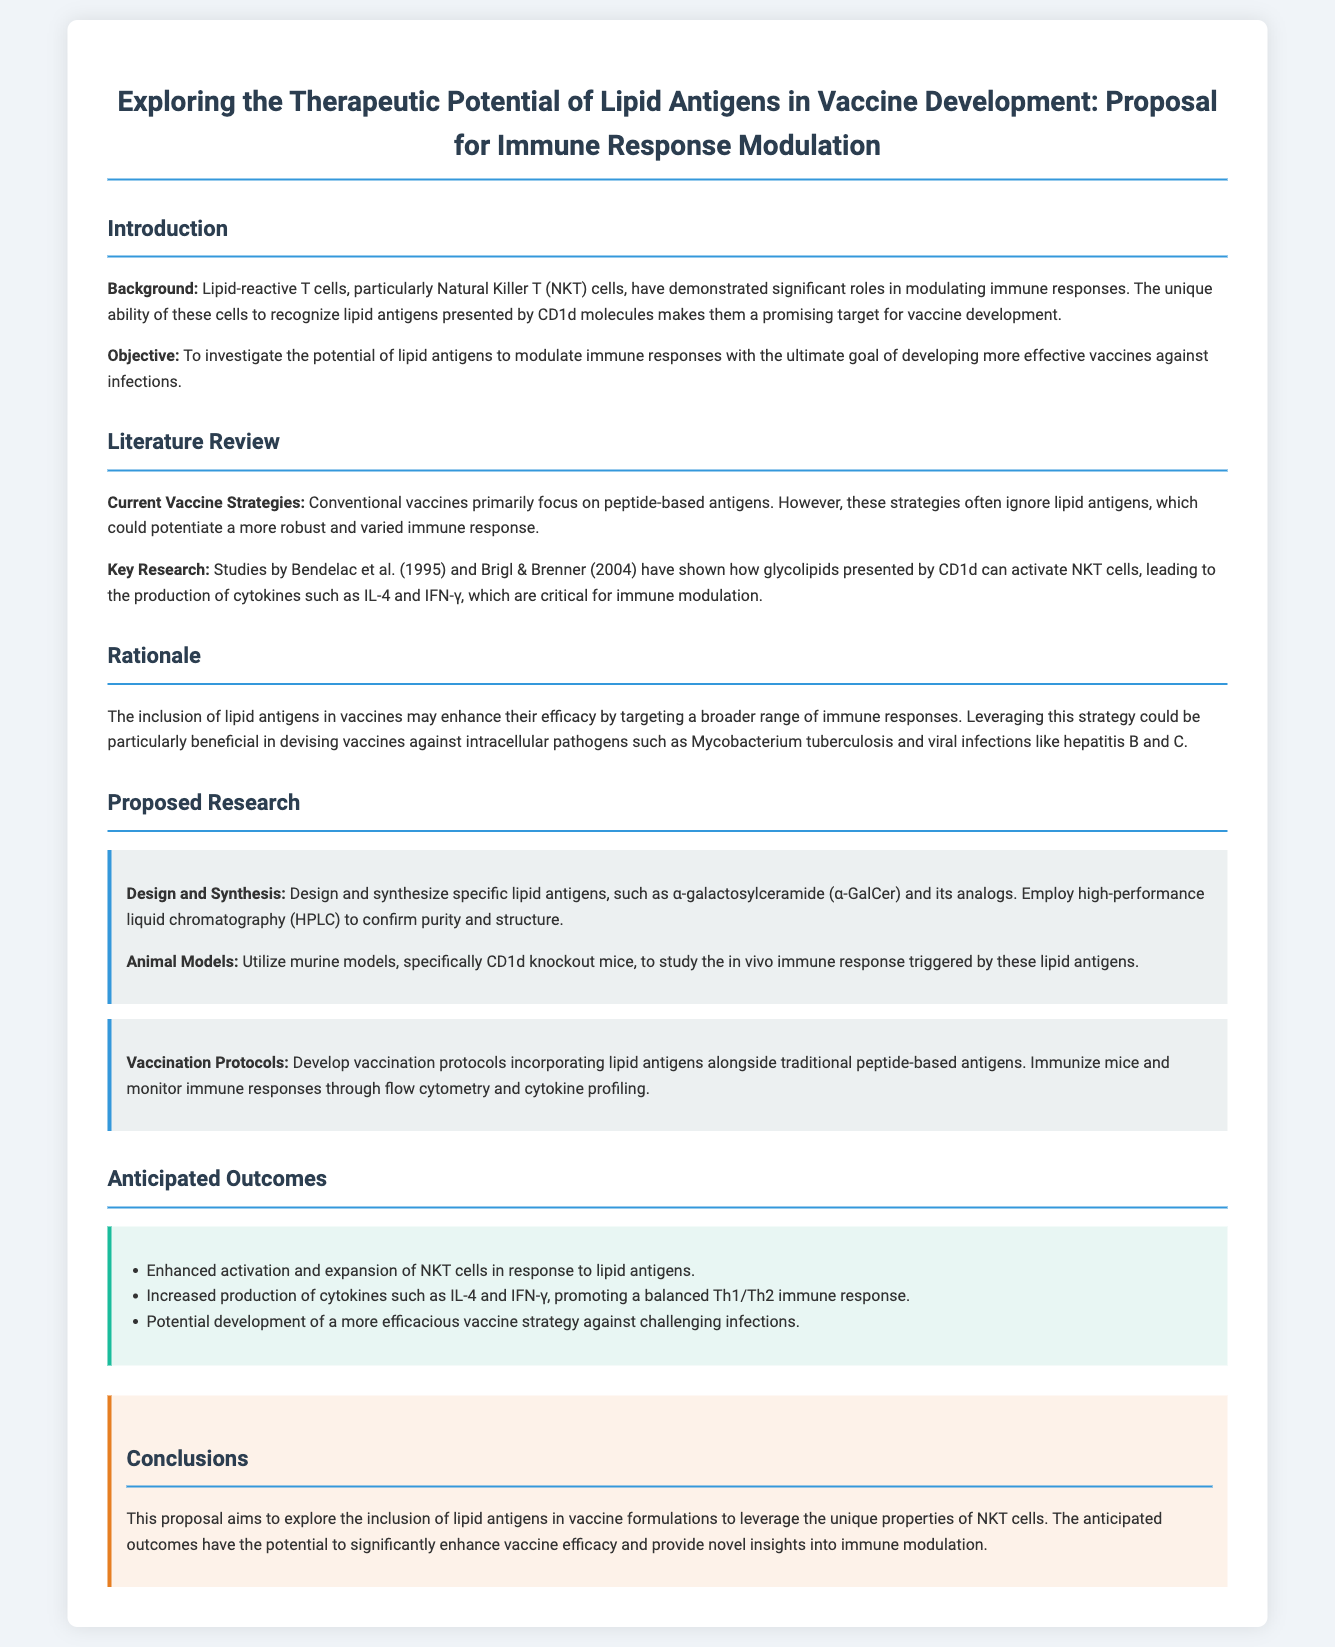What is the title of the proposal? The title of the proposal is listed prominently at the beginning, which outlines the focus on lipid antigens and vaccine development.
Answer: Exploring the Therapeutic Potential of Lipid Antigens in Vaccine Development: Proposal for Immune Response Modulation Who are the key researchers mentioned in the literature review? The document cites studies by Bendelac et al. (1995) and Brigl & Brenner (2004) as key research contributions.
Answer: Bendelac et al. (1995) and Brigl & Brenner (2004) What is the primary goal of the proposal? The primary goal is specified in the objective section, focusing on the investigation of lipid antigens to modulate immune responses.
Answer: To investigate the potential of lipid antigens to modulate immune responses Which animal models are proposed for the study? The document states that murine models, specifically CD1d knockout mice, will be utilized for the research.
Answer: CD1d knockout mice What cytokines are expected to increase with lipid antigen stimulation? The anticipated increase in specific cytokines is highlighted in the outcomes section, focusing on immune response modulation.
Answer: IL-4 and IFN-γ How will the effectiveness of lipid antigens be measured? The proposal outlines using flow cytometry and cytokine profiling to monitor immune responses post-immunization.
Answer: Flow cytometry and cytokine profiling What potential global health issue does the proposal aim to address? The rationale discusses targeting challenging infections, particularly intracellular pathogens like Mycobacterium tuberculosis and viral infections.
Answer: Mycobacterium tuberculosis and viral infections What are the anticipated outcomes of including lipid antigens in vaccines? The outcome section lists expected improvements such as enhanced activation of NKT cells and cytokine production.
Answer: Enhanced activation and expansion of NKT cells 